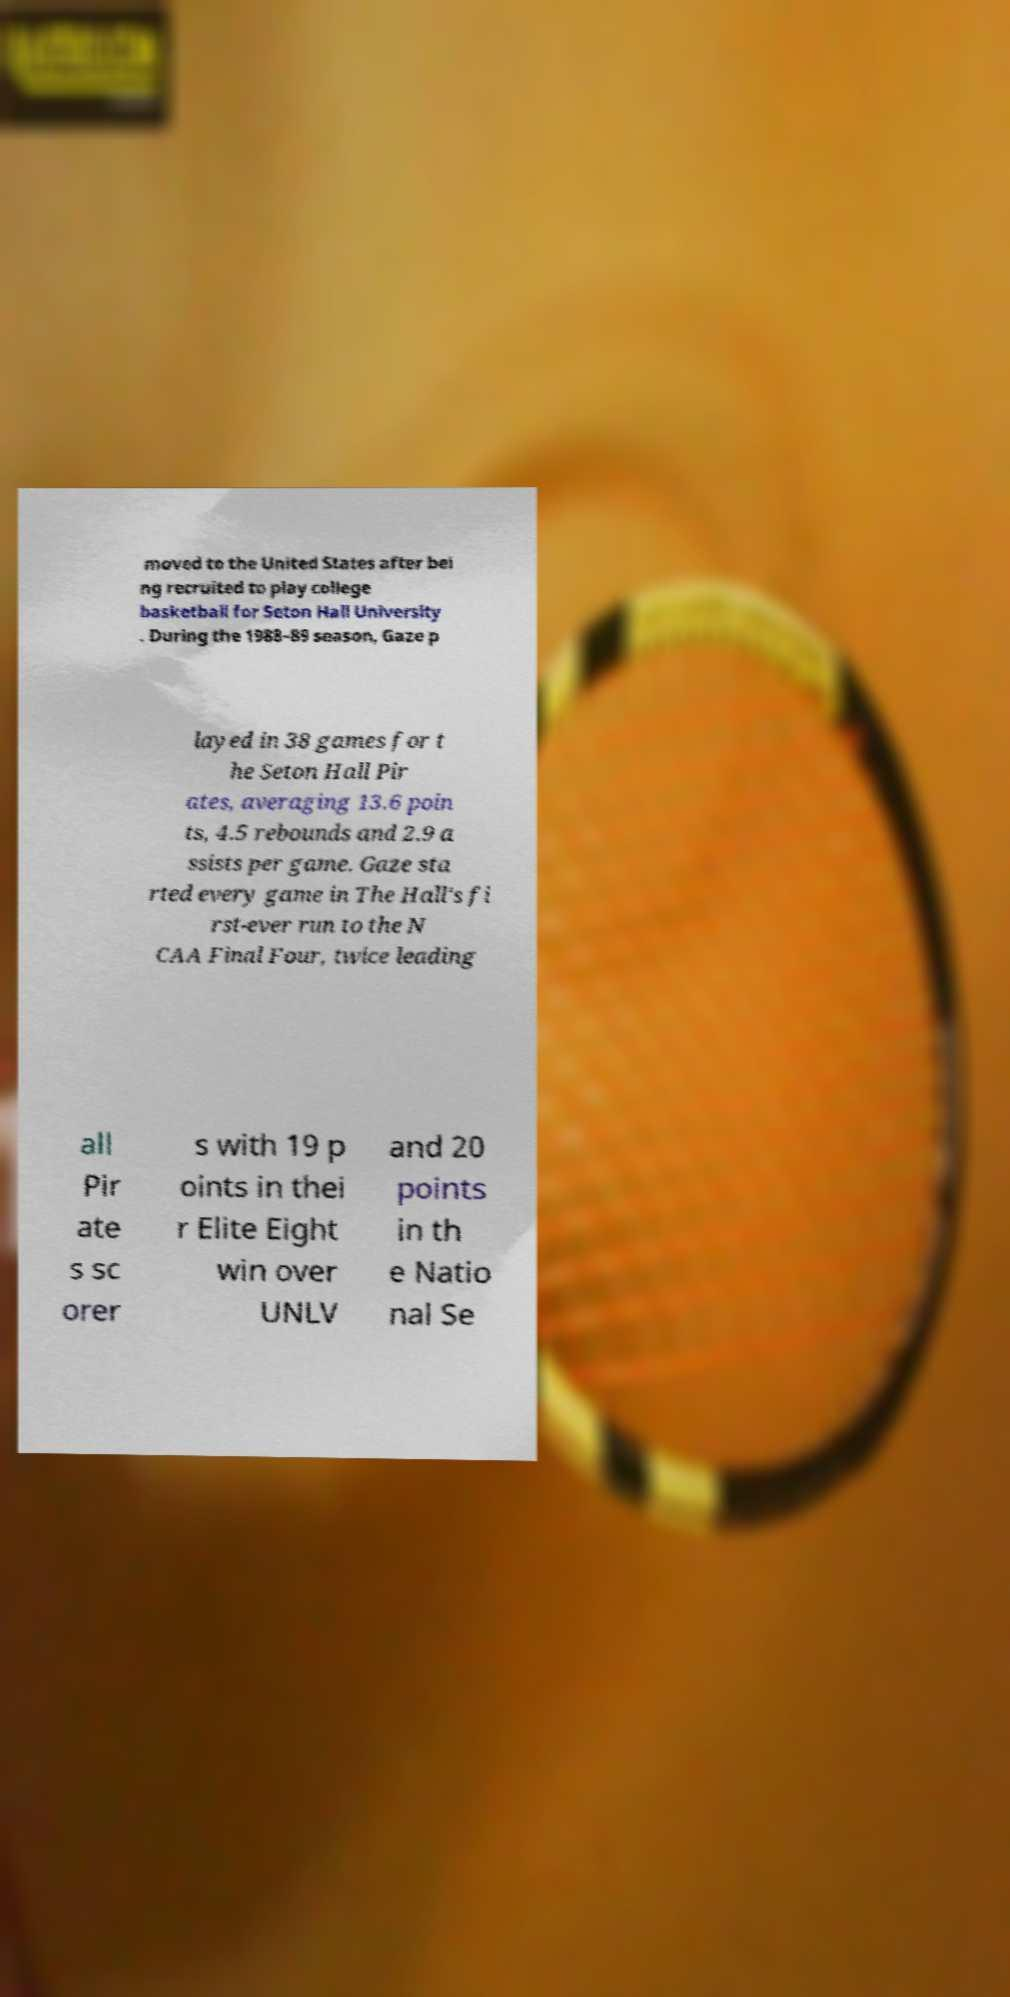Please identify and transcribe the text found in this image. moved to the United States after bei ng recruited to play college basketball for Seton Hall University . During the 1988–89 season, Gaze p layed in 38 games for t he Seton Hall Pir ates, averaging 13.6 poin ts, 4.5 rebounds and 2.9 a ssists per game. Gaze sta rted every game in The Hall's fi rst-ever run to the N CAA Final Four, twice leading all Pir ate s sc orer s with 19 p oints in thei r Elite Eight win over UNLV and 20 points in th e Natio nal Se 